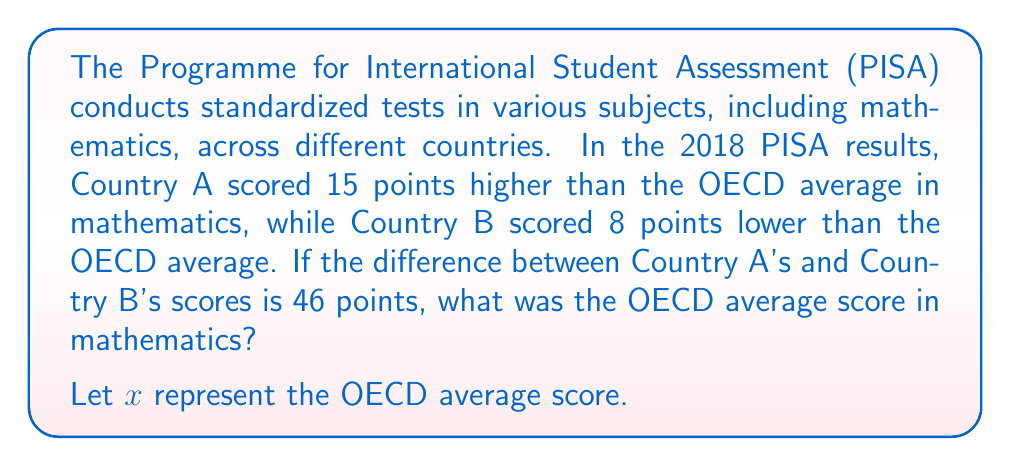Teach me how to tackle this problem. Let's approach this step-by-step:

1) Let's define our variables:
   $x$ = OECD average score
   Country A's score = $x + 15$
   Country B's score = $x - 8$

2) We're told that the difference between Country A's and Country B's scores is 46 points. We can express this as an equation:

   $$(x + 15) - (x - 8) = 46$$

3) Let's solve this equation:
   
   $x + 15 - x + 8 = 46$
   
   $23 = 46$
   
4) Simplify:
   
   $23 = 46$

5) Solve for $x$:
   
   $x = 46 - 23 = 23$

Therefore, the OECD average score was 489 points.
Answer: 489 points 